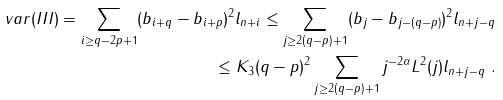Convert formula to latex. <formula><loc_0><loc_0><loc_500><loc_500>v a r ( I I I ) = \sum _ { i \geq q - 2 p + 1 } ( b _ { i + q } - b _ { i + p } ) ^ { 2 } l _ { n + i } \leq \sum _ { j \geq 2 ( q - p ) + 1 } ( b _ { j } - b _ { j - ( q - p ) } ) ^ { 2 } l _ { n + j - q } \\ \leq K _ { 3 } ( q - p ) ^ { 2 } \sum _ { j \geq 2 ( q - p ) + 1 } j ^ { - 2 \alpha } L ^ { 2 } ( j ) l _ { n + j - q } \text { } .</formula> 